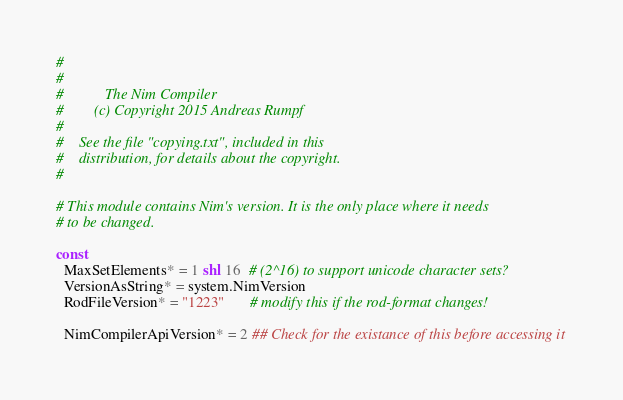Convert code to text. <code><loc_0><loc_0><loc_500><loc_500><_Nim_>#
#
#           The Nim Compiler
#        (c) Copyright 2015 Andreas Rumpf
#
#    See the file "copying.txt", included in this
#    distribution, for details about the copyright.
#

# This module contains Nim's version. It is the only place where it needs
# to be changed.

const
  MaxSetElements* = 1 shl 16  # (2^16) to support unicode character sets?
  VersionAsString* = system.NimVersion
  RodFileVersion* = "1223"       # modify this if the rod-format changes!

  NimCompilerApiVersion* = 2 ## Check for the existance of this before accessing it</code> 